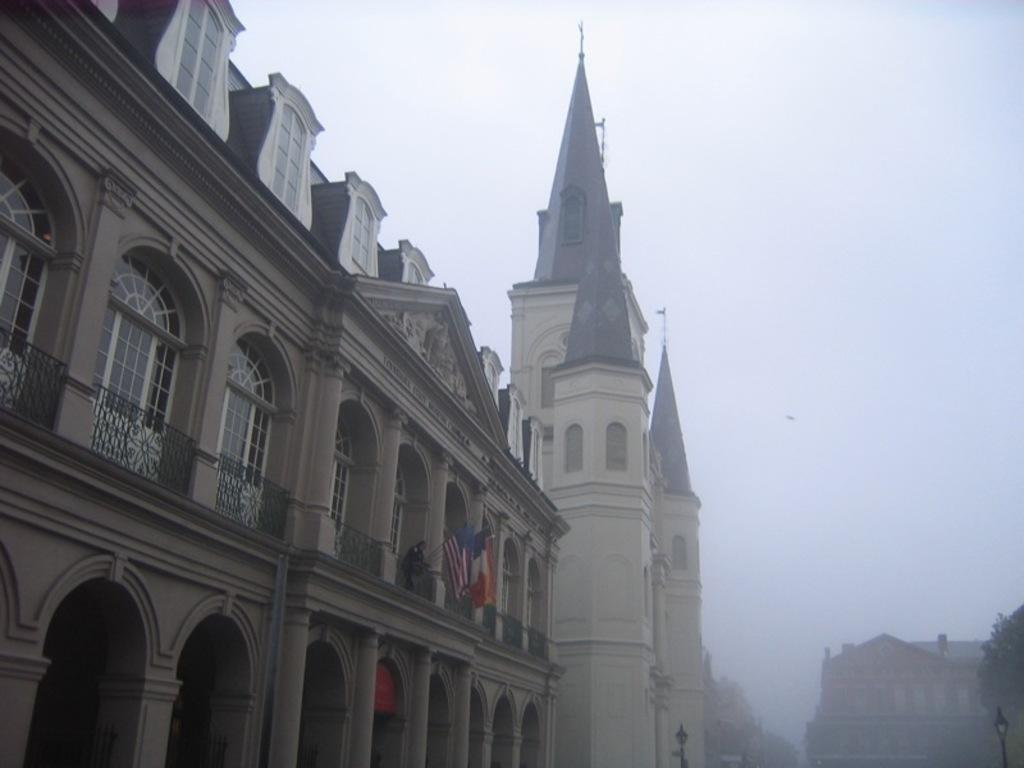What type of structure is present in the image? There is a building in the image. What feature can be seen on the building? The building has windows. What national symbols are visible in the image? There are flags of the country in the image. What type of plant is present in the image? There is a tree in the image. What part of the natural environment is visible in the image? The sky is visible in the image. Can you see a person jumping in the image? There is no person visible in the image, let alone someone jumping. 